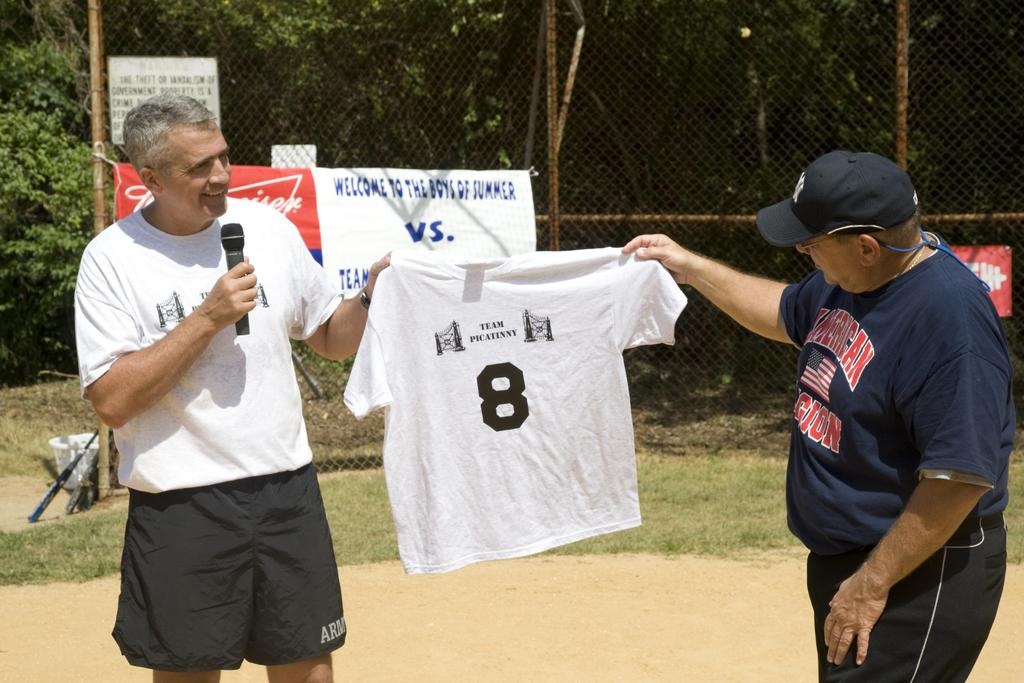<image>
Relay a brief, clear account of the picture shown. Two men hold a t-shirt with the number 8 on it between them. 